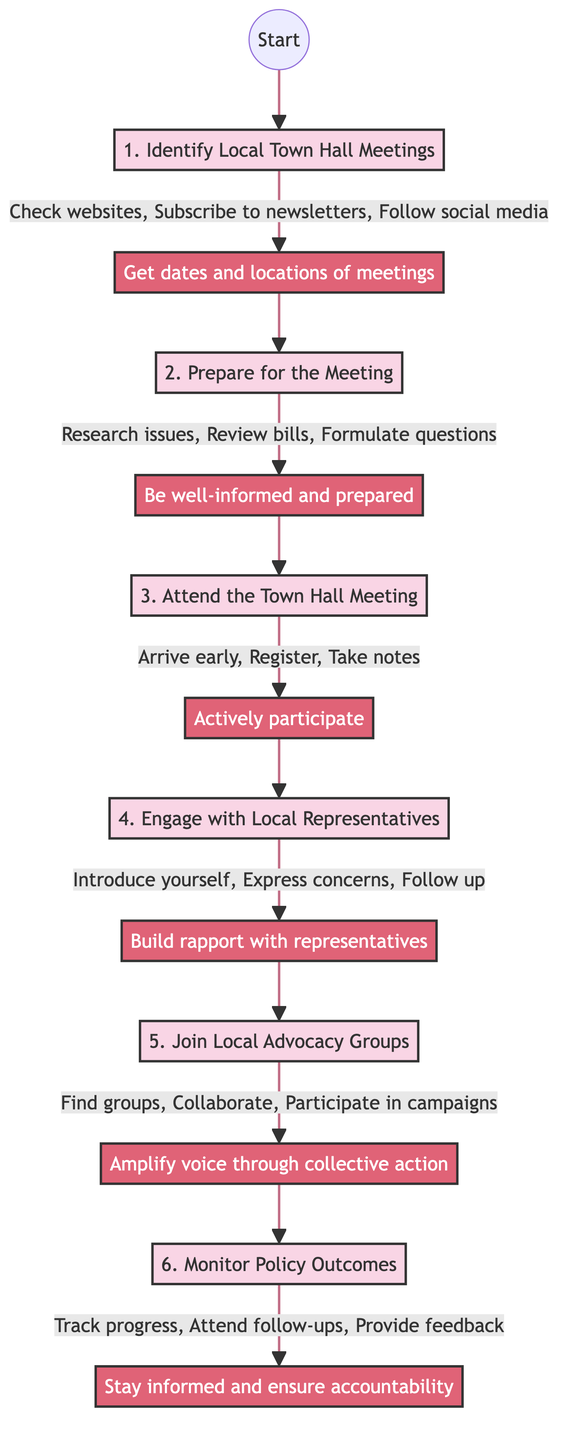What is the first step in the process? The diagram clearly labels the first step as "1. Identify Local Town Hall Meetings." This step initiates the process of participating in town hall meetings.
Answer: 1. Identify Local Town Hall Meetings How many steps are outlined in the diagram? By counting the distinct steps presented—from Step 1 to Step 6—I find that there are a total of six steps in the decision tree.
Answer: 6 What is the outcome of Step 2? According to the diagram, the outcome of Step 2 is "Be well-informed and prepared to engage in discussions," which indicates the goal of the actions taken in that step.
Answer: Be well-informed and prepared What actions are suggested in Step 5? The diagram details three actions to be completed in Step 5: "Find groups, Collaborate, Participate in campaigns." These actions focus on community involvement and collective advocacy.
Answer: Find groups, Collaborate, Participate in campaigns What is the relationship between Step 3 and Step 4? Step 3 is followed by Step 4; specifically, the outcome of Step 3—"Actively participate and understand the proceedings"—leads into the next action of engaging with local representatives in Step 4.
Answer: Step 3 leads to Step 4 What is the last outcome mentioned in the diagram? The final step, Step 6, has the outcome "Stay informed and ensure accountability." This indicates the ultimate goal of ongoing engagement in local politics as outlined in this process.
Answer: Stay informed and ensure accountability What should you do after engaging with local representatives in Step 4? The diagram indicates that after engaging with local representatives, one should "Follow up via email or social media after the meeting," suggesting a continued connection is vital.
Answer: Follow up via email or social media Which step involves joining local advocacy groups? The diagram explicitly states that Step 5 is focused on joining local advocacy groups, emphasizing the importance of community participation in policy influence.
Answer: Join Local Advocacy Groups What type of actions are described in the diagram for Step 1? The actions in Step 1 include practical tasks such as "Check websites, Subscribe to newsletters, Follow social media," which are aimed at gathering information about local town hall meetings.
Answer: Check websites, Subscribe to newsletters, Follow social media 